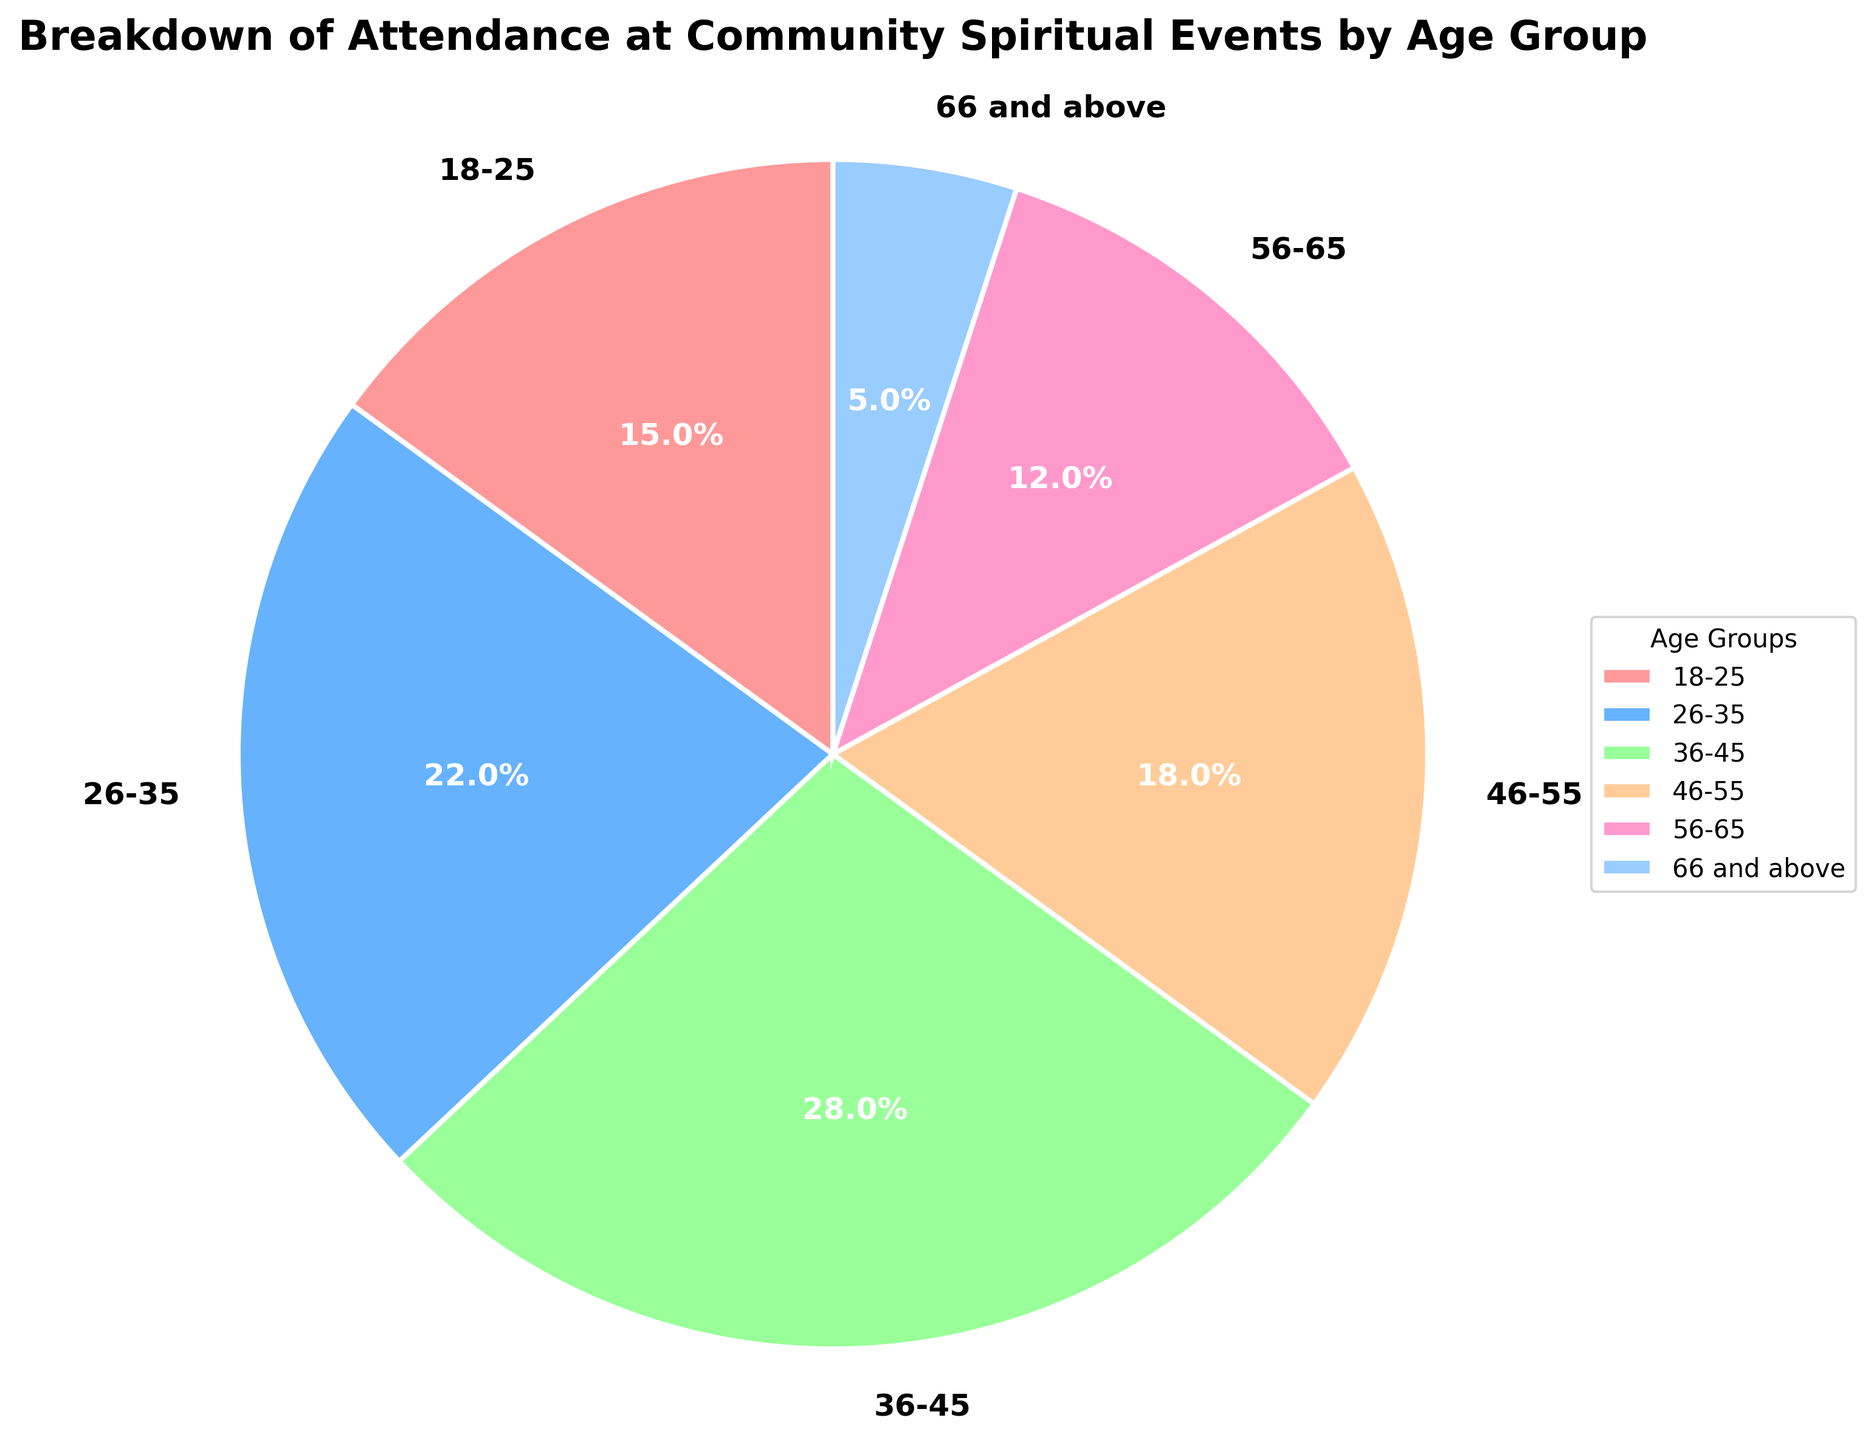What age group has the highest attendance percentage? The figure shows the attendance percentage for each age group. By examining the pie chart, we can see which slice of the pie is the largest. The group 36-45 has the highest attendance percentage at 28%.
Answer: 36-45 Which age group has the lowest attendance percentage? The smallest slice of the pie chart represents the age group 66 and above, which has an attendance percentage of 5%.
Answer: 66 and above What is the combined attendance percentage for the age groups 18-25 and 56-65? Add the attendance percentages of the age groups 18-25 (15%) and 56-65 (12%). 15% + 12% = 27%.
Answer: 27% How much greater is the attendance percentage of the 36-45 age group compared to the 66 and above age group? Subtract the attendance percentage of the 66 and above age group (5%) from the 36-45 age group (28%). 28% - 5% = 23%.
Answer: 23% Which age groups have an attendance percentage above 20%? Examining the pie chart, the age groups with an attendance percentage above 20% are 26-35 (22%) and 36-45 (28%).
Answer: 26-35, 36-45 What is the average attendance percentage of the age groups under 46? Sum the attendance percentages of the age groups under 46 (i.e., 18-25, 26-35, 36-45) and divide by the number of groups. (15% + 22% + 28%) / 3 = 65% / 3 = 21.67%.
Answer: 21.67% Compared to the 18-25 age group, how much higher is the attendance percentage of the 36-45 age group? Subtract the attendance percentage of the 18-25 age group (15%) from the 36-45 age group (28%). 28% - 15% = 13%.
Answer: 13% What is the total attendance percentage of the age groups 46-55 and 56-65 combined? Add the attendance percentages of the age groups 46-55 (18%) and 56-65 (12%). 18% + 12% = 30%.
Answer: 30% What color represents the 26-35 age group in the pie chart? The pie chart uses a custom color palette, and the 26-35 age group is represented by a blue slice.
Answer: blue 